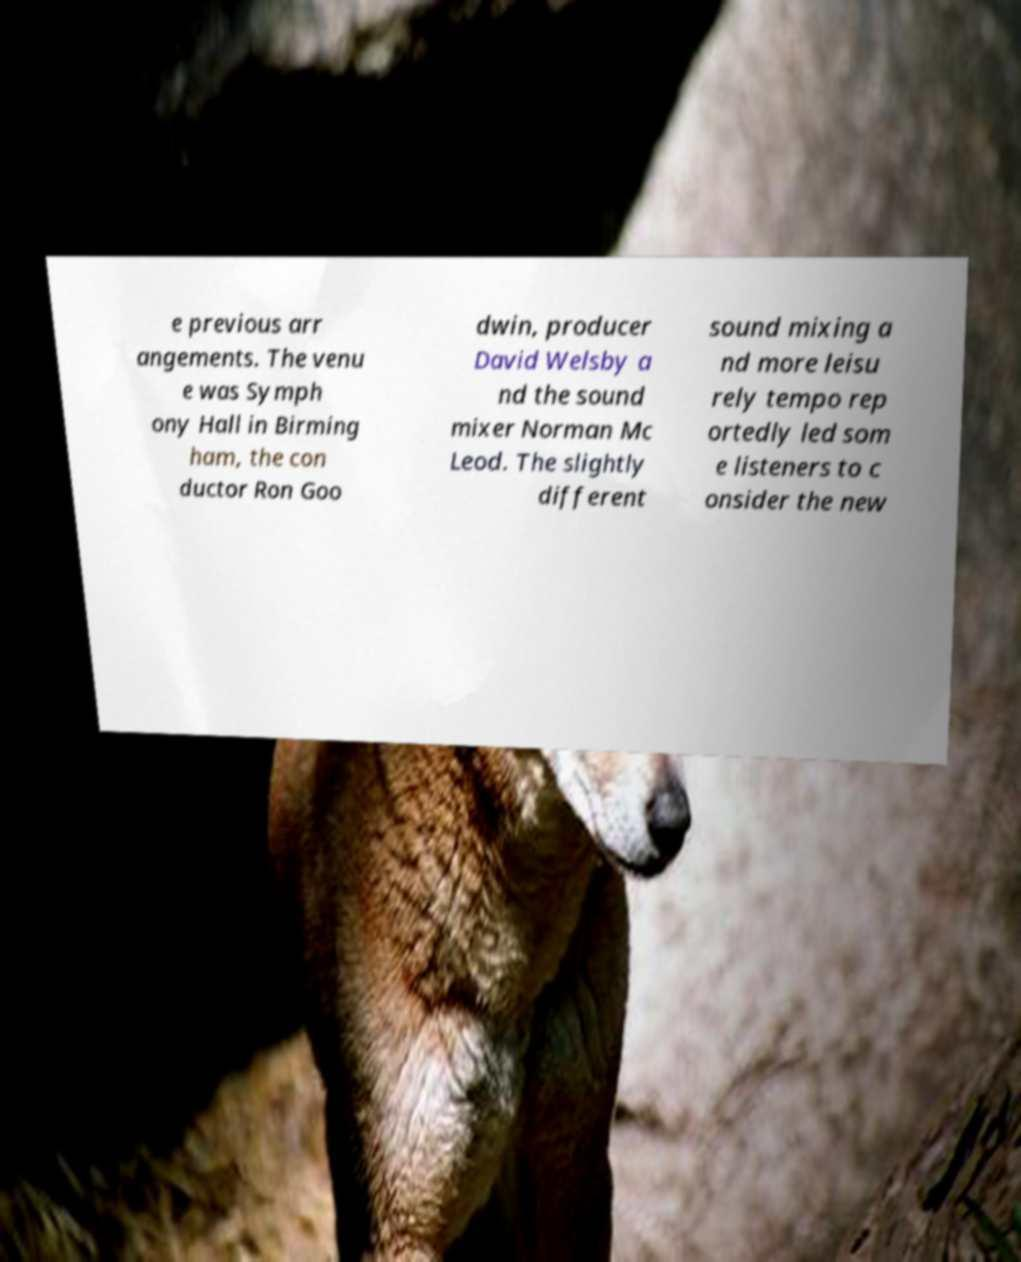What messages or text are displayed in this image? I need them in a readable, typed format. e previous arr angements. The venu e was Symph ony Hall in Birming ham, the con ductor Ron Goo dwin, producer David Welsby a nd the sound mixer Norman Mc Leod. The slightly different sound mixing a nd more leisu rely tempo rep ortedly led som e listeners to c onsider the new 